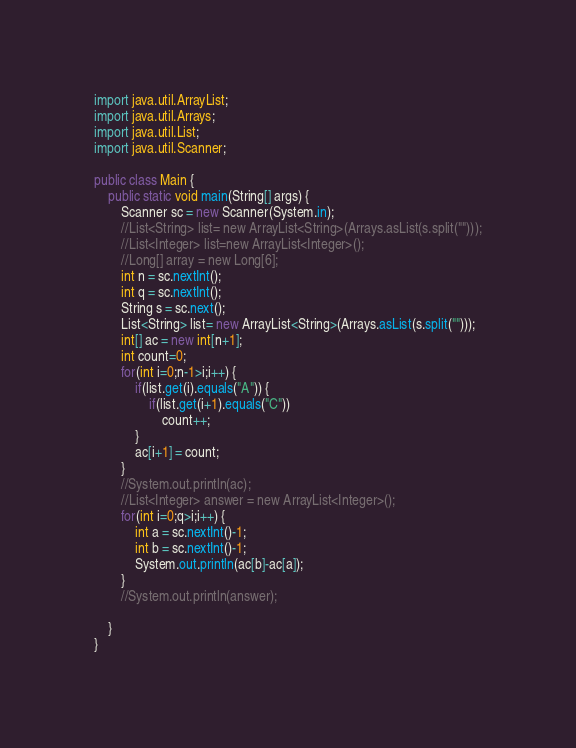<code> <loc_0><loc_0><loc_500><loc_500><_Java_>import java.util.ArrayList;
import java.util.Arrays;
import java.util.List;
import java.util.Scanner;

public class Main {
	public static void main(String[] args) {
		Scanner sc = new Scanner(System.in);
		//List<String> list= new ArrayList<String>(Arrays.asList(s.split("")));
		//List<Integer> list=new ArrayList<Integer>();
		//Long[] array = new Long[6];
        int n = sc.nextInt();
        int q = sc.nextInt();
        String s = sc.next();
        List<String> list= new ArrayList<String>(Arrays.asList(s.split("")));
        int[] ac = new int[n+1];
        int count=0;
        for(int i=0;n-1>i;i++) {
        	if(list.get(i).equals("A")) {
        		if(list.get(i+1).equals("C"))
        			count++;
        	}
        	ac[i+1] = count;
        }
        //System.out.println(ac);
        //List<Integer> answer = new ArrayList<Integer>();
        for(int i=0;q>i;i++) {
        	int a = sc.nextInt()-1;
        	int b = sc.nextInt()-1;
        	System.out.println(ac[b]-ac[a]);
        }
        //System.out.println(answer);

	}
}</code> 